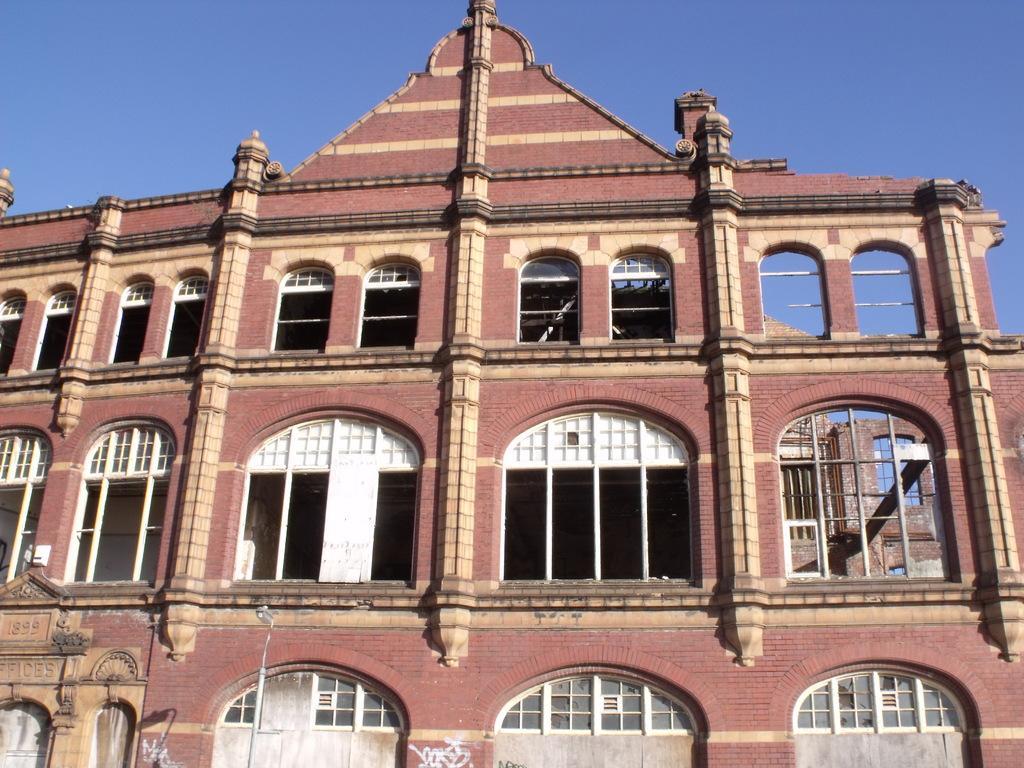Could you give a brief overview of what you see in this image? In the bottom left corner of the image there is a pole. In the middle of the image there is a building. At the top of the image there is sky. 